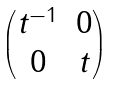Convert formula to latex. <formula><loc_0><loc_0><loc_500><loc_500>\begin{pmatrix} t ^ { - 1 } & 0 \\ 0 & t \end{pmatrix}</formula> 